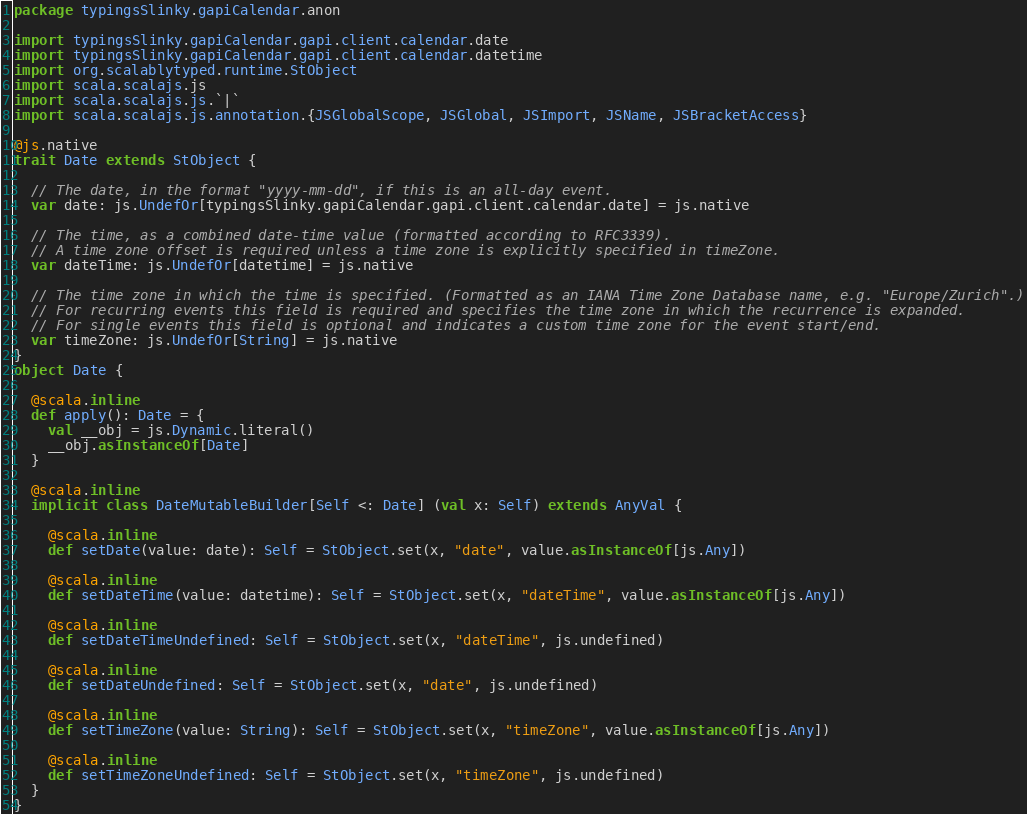Convert code to text. <code><loc_0><loc_0><loc_500><loc_500><_Scala_>package typingsSlinky.gapiCalendar.anon

import typingsSlinky.gapiCalendar.gapi.client.calendar.date
import typingsSlinky.gapiCalendar.gapi.client.calendar.datetime
import org.scalablytyped.runtime.StObject
import scala.scalajs.js
import scala.scalajs.js.`|`
import scala.scalajs.js.annotation.{JSGlobalScope, JSGlobal, JSImport, JSName, JSBracketAccess}

@js.native
trait Date extends StObject {
  
  // The date, in the format "yyyy-mm-dd", if this is an all-day event.
  var date: js.UndefOr[typingsSlinky.gapiCalendar.gapi.client.calendar.date] = js.native
  
  // The time, as a combined date-time value (formatted according to RFC3339).
  // A time zone offset is required unless a time zone is explicitly specified in timeZone.
  var dateTime: js.UndefOr[datetime] = js.native
  
  // The time zone in which the time is specified. (Formatted as an IANA Time Zone Database name, e.g. "Europe/Zurich".)
  // For recurring events this field is required and specifies the time zone in which the recurrence is expanded.
  // For single events this field is optional and indicates a custom time zone for the event start/end.
  var timeZone: js.UndefOr[String] = js.native
}
object Date {
  
  @scala.inline
  def apply(): Date = {
    val __obj = js.Dynamic.literal()
    __obj.asInstanceOf[Date]
  }
  
  @scala.inline
  implicit class DateMutableBuilder[Self <: Date] (val x: Self) extends AnyVal {
    
    @scala.inline
    def setDate(value: date): Self = StObject.set(x, "date", value.asInstanceOf[js.Any])
    
    @scala.inline
    def setDateTime(value: datetime): Self = StObject.set(x, "dateTime", value.asInstanceOf[js.Any])
    
    @scala.inline
    def setDateTimeUndefined: Self = StObject.set(x, "dateTime", js.undefined)
    
    @scala.inline
    def setDateUndefined: Self = StObject.set(x, "date", js.undefined)
    
    @scala.inline
    def setTimeZone(value: String): Self = StObject.set(x, "timeZone", value.asInstanceOf[js.Any])
    
    @scala.inline
    def setTimeZoneUndefined: Self = StObject.set(x, "timeZone", js.undefined)
  }
}
</code> 